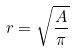<formula> <loc_0><loc_0><loc_500><loc_500>r = \sqrt { \frac { A } { \pi } }</formula> 